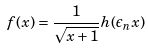<formula> <loc_0><loc_0><loc_500><loc_500>f ( x ) = \frac { 1 } { \sqrt { x + 1 } } h ( \epsilon _ { n } x )</formula> 